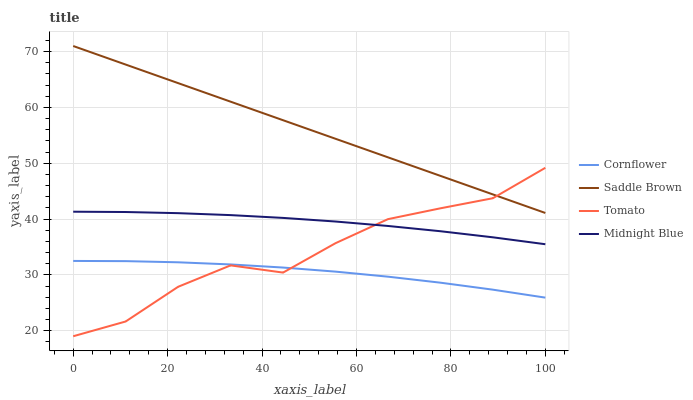Does Saddle Brown have the minimum area under the curve?
Answer yes or no. No. Does Cornflower have the maximum area under the curve?
Answer yes or no. No. Is Cornflower the smoothest?
Answer yes or no. No. Is Cornflower the roughest?
Answer yes or no. No. Does Cornflower have the lowest value?
Answer yes or no. No. Does Cornflower have the highest value?
Answer yes or no. No. Is Cornflower less than Saddle Brown?
Answer yes or no. Yes. Is Saddle Brown greater than Cornflower?
Answer yes or no. Yes. Does Cornflower intersect Saddle Brown?
Answer yes or no. No. 